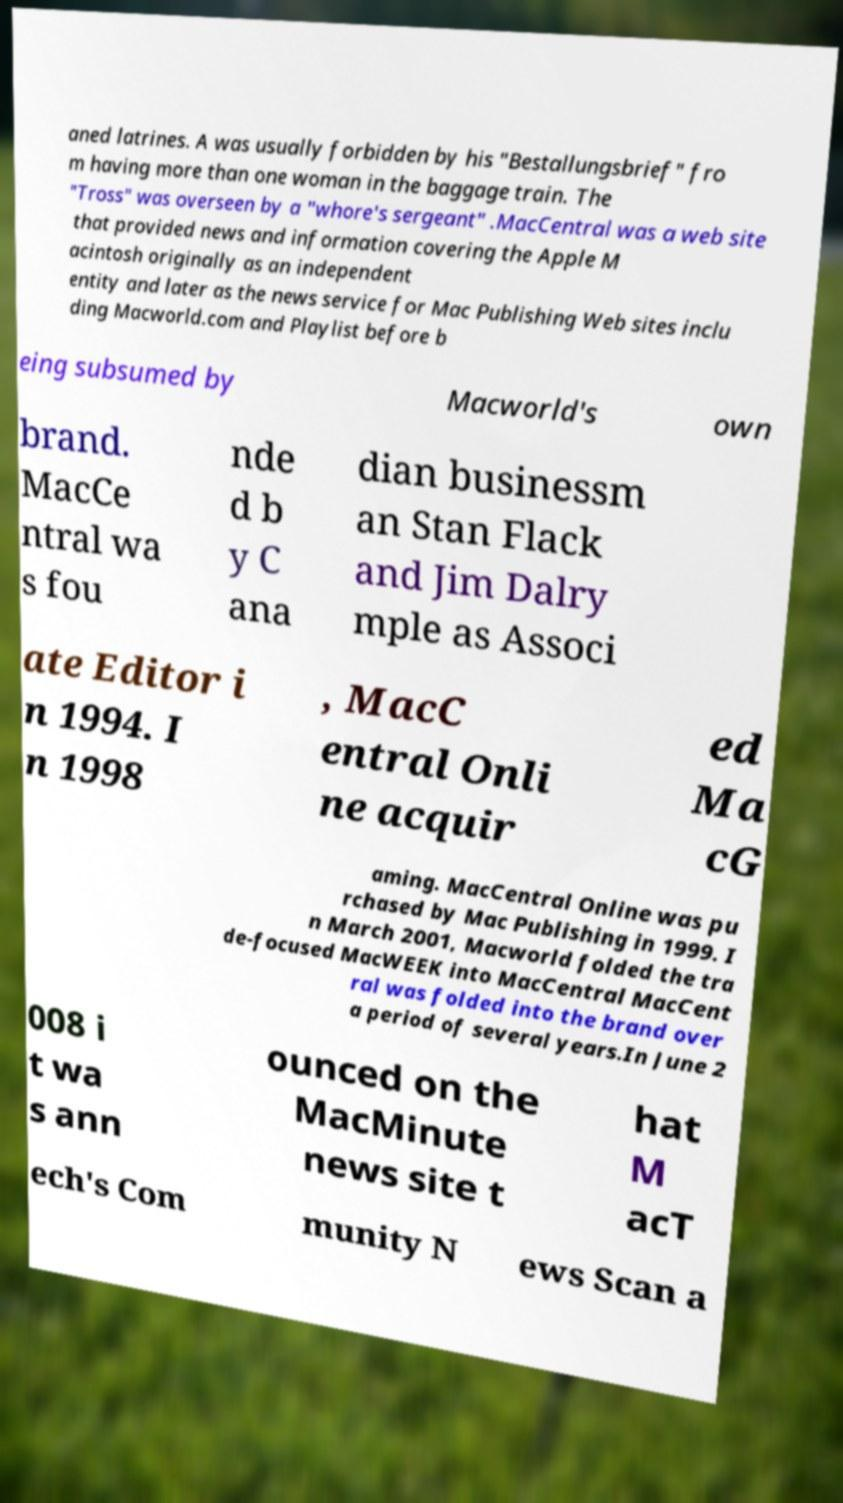Please identify and transcribe the text found in this image. aned latrines. A was usually forbidden by his "Bestallungsbrief" fro m having more than one woman in the baggage train. The "Tross" was overseen by a "whore's sergeant" .MacCentral was a web site that provided news and information covering the Apple M acintosh originally as an independent entity and later as the news service for Mac Publishing Web sites inclu ding Macworld.com and Playlist before b eing subsumed by Macworld's own brand. MacCe ntral wa s fou nde d b y C ana dian businessm an Stan Flack and Jim Dalry mple as Associ ate Editor i n 1994. I n 1998 , MacC entral Onli ne acquir ed Ma cG aming. MacCentral Online was pu rchased by Mac Publishing in 1999. I n March 2001, Macworld folded the tra de-focused MacWEEK into MacCentral MacCent ral was folded into the brand over a period of several years.In June 2 008 i t wa s ann ounced on the MacMinute news site t hat M acT ech's Com munity N ews Scan a 